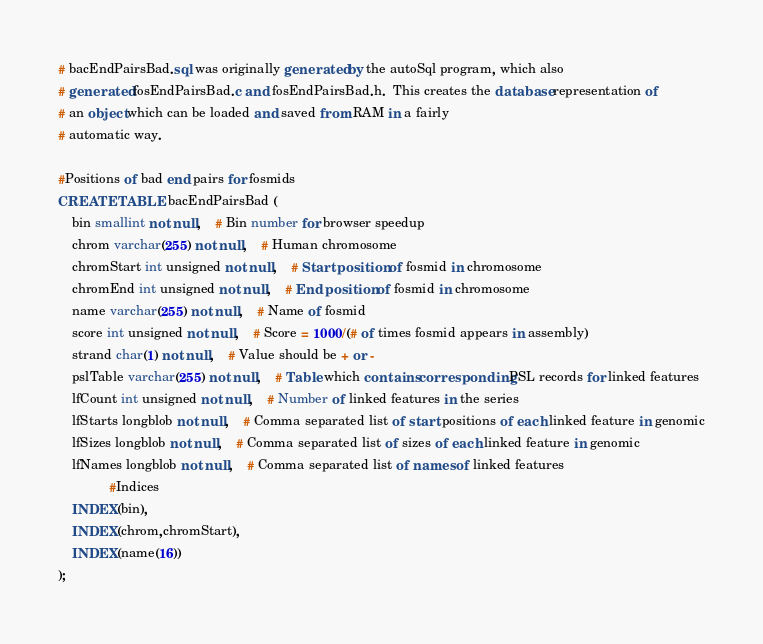Convert code to text. <code><loc_0><loc_0><loc_500><loc_500><_SQL_># bacEndPairsBad.sql was originally generated by the autoSql program, which also 
# generated fosEndPairsBad.c and fosEndPairsBad.h.  This creates the database representation of
# an object which can be loaded and saved from RAM in a fairly 
# automatic way.

#Positions of bad end pairs for fosmids
CREATE TABLE bacEndPairsBad (
    bin smallint not null,	# Bin number for browser speedup
    chrom varchar(255) not null,	# Human chromosome
    chromStart int unsigned not null,	# Start position of fosmid in chromosome
    chromEnd int unsigned not null,	# End position of fosmid in chromosome
    name varchar(255) not null,	# Name of fosmid
    score int unsigned not null,	# Score = 1000/(# of times fosmid appears in assembly)
    strand char(1) not null,	# Value should be + or -
    pslTable varchar(255) not null,	# Table which contains corresponding PSL records for linked features
    lfCount int unsigned not null,	# Number of linked features in the series
    lfStarts longblob not null,	# Comma separated list of start positions of each linked feature in genomic
    lfSizes longblob not null,	# Comma separated list of sizes of each linked feature in genomic
    lfNames longblob not null,	# Comma separated list of names of linked features
              #Indices
    INDEX(bin),
    INDEX(chrom,chromStart),
    INDEX(name(16))
);
</code> 